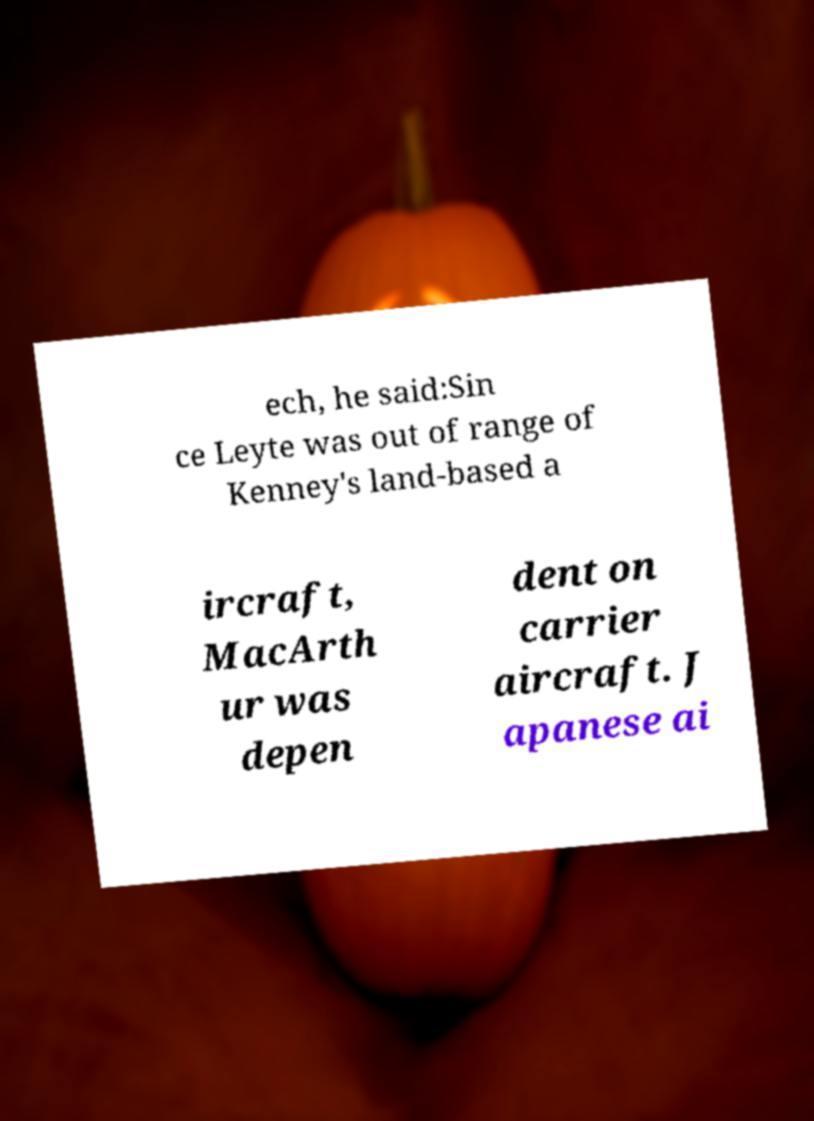Could you extract and type out the text from this image? ech, he said:Sin ce Leyte was out of range of Kenney's land-based a ircraft, MacArth ur was depen dent on carrier aircraft. J apanese ai 